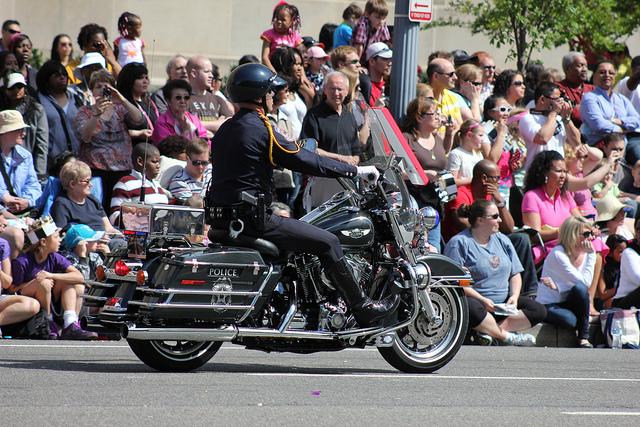Are all the people sitting on benches?
Be succinct. No. How many police officers are in this scene?
Quick response, please. 1. What event is this?
Short answer required. Parade. 